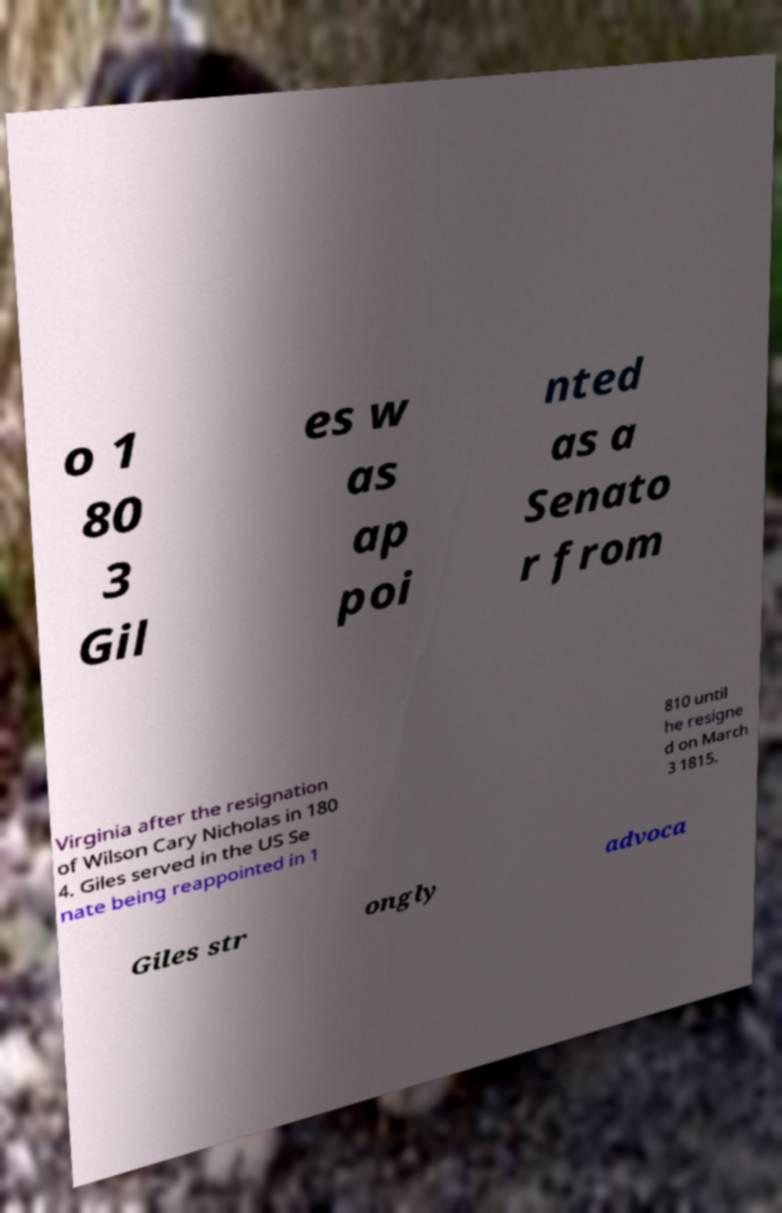Can you accurately transcribe the text from the provided image for me? o 1 80 3 Gil es w as ap poi nted as a Senato r from Virginia after the resignation of Wilson Cary Nicholas in 180 4. Giles served in the US Se nate being reappointed in 1 810 until he resigne d on March 3 1815. Giles str ongly advoca 